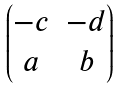Convert formula to latex. <formula><loc_0><loc_0><loc_500><loc_500>\begin{pmatrix} - c & - d \\ a & b \\ \end{pmatrix}</formula> 